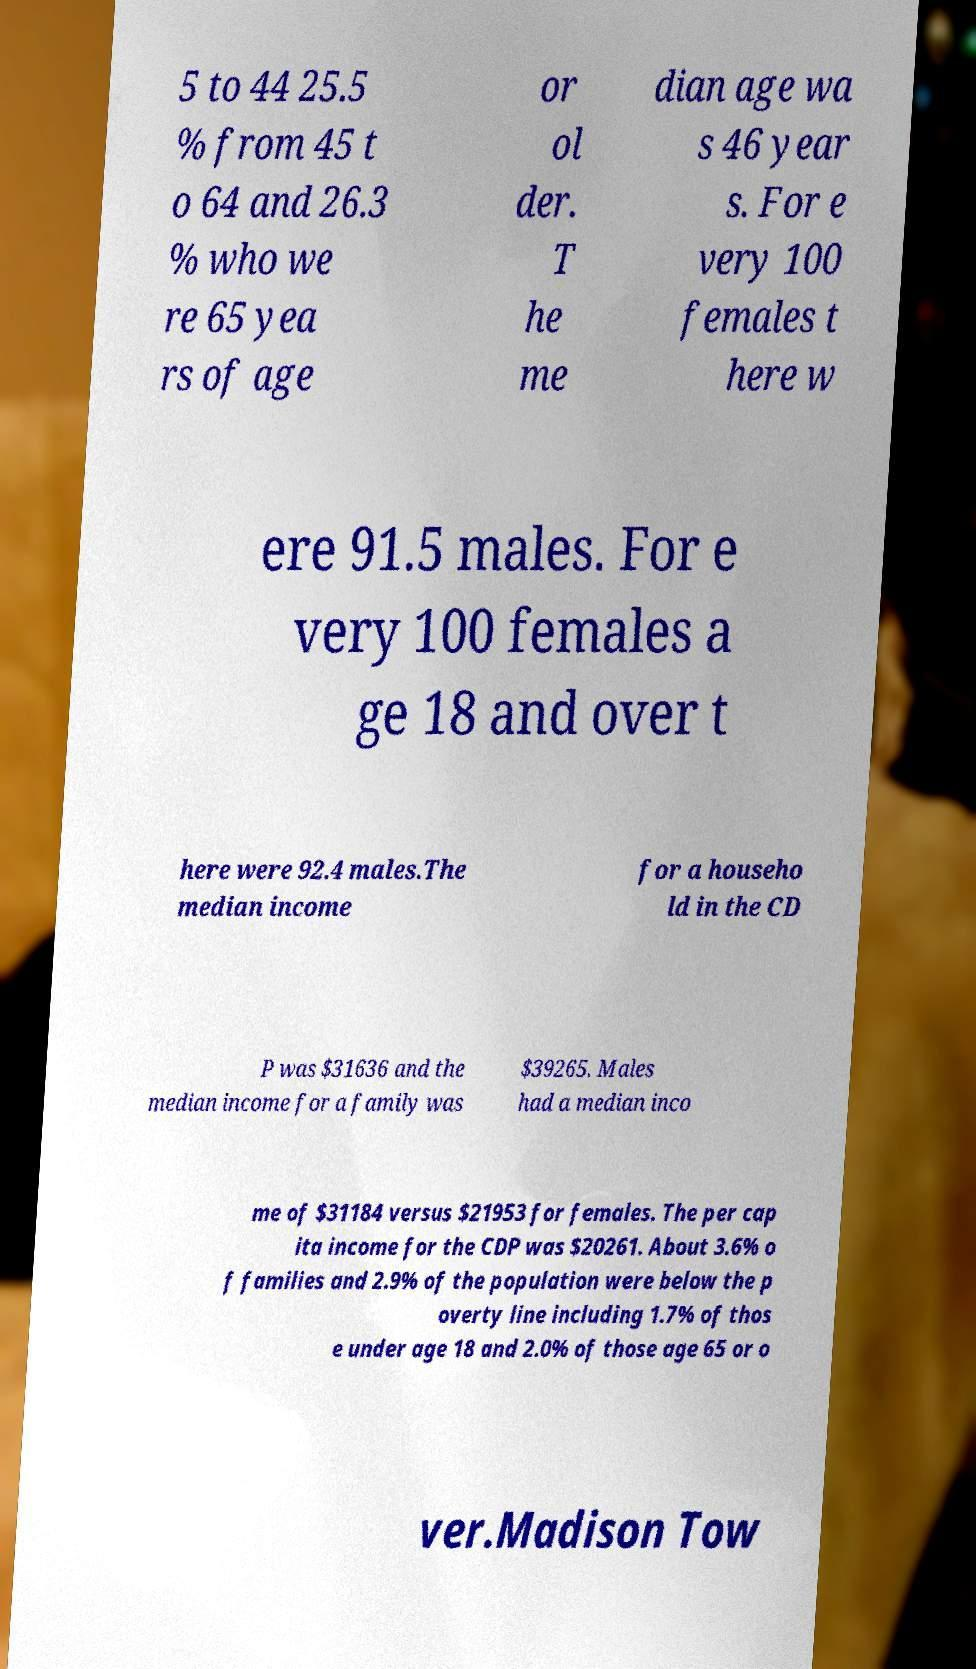Could you extract and type out the text from this image? 5 to 44 25.5 % from 45 t o 64 and 26.3 % who we re 65 yea rs of age or ol der. T he me dian age wa s 46 year s. For e very 100 females t here w ere 91.5 males. For e very 100 females a ge 18 and over t here were 92.4 males.The median income for a househo ld in the CD P was $31636 and the median income for a family was $39265. Males had a median inco me of $31184 versus $21953 for females. The per cap ita income for the CDP was $20261. About 3.6% o f families and 2.9% of the population were below the p overty line including 1.7% of thos e under age 18 and 2.0% of those age 65 or o ver.Madison Tow 